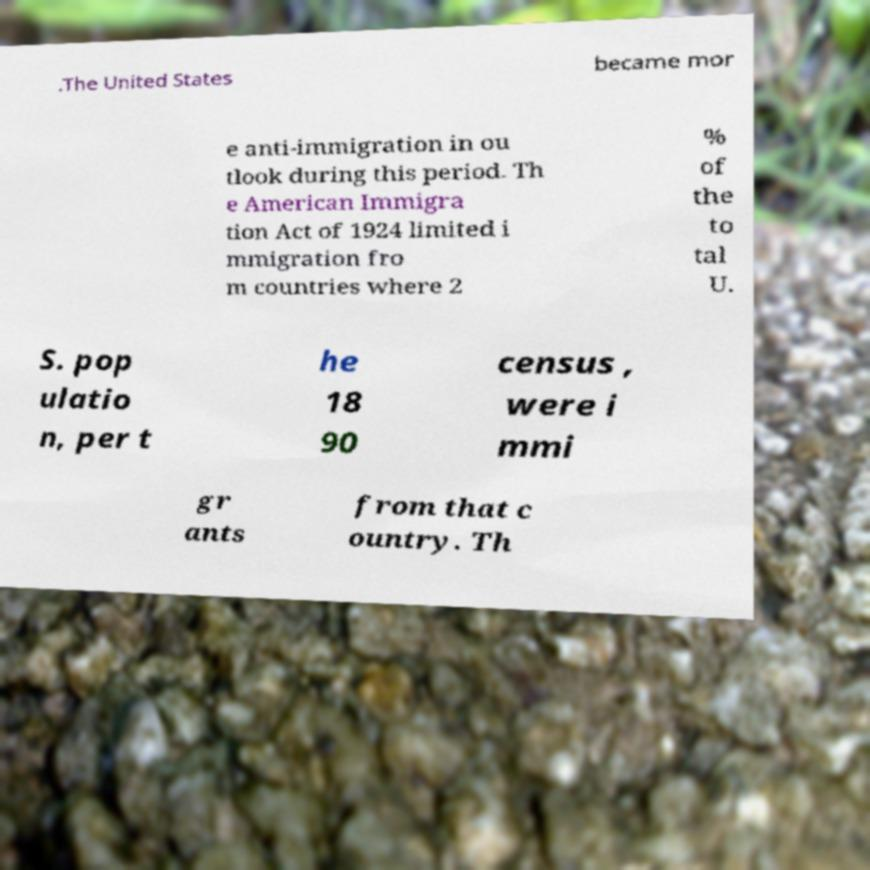Please identify and transcribe the text found in this image. .The United States became mor e anti-immigration in ou tlook during this period. Th e American Immigra tion Act of 1924 limited i mmigration fro m countries where 2 % of the to tal U. S. pop ulatio n, per t he 18 90 census , were i mmi gr ants from that c ountry. Th 